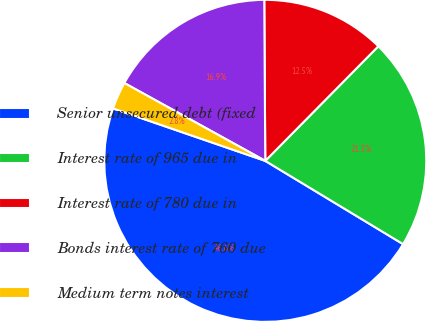Convert chart to OTSL. <chart><loc_0><loc_0><loc_500><loc_500><pie_chart><fcel>Senior unsecured debt (fixed<fcel>Interest rate of 965 due in<fcel>Interest rate of 780 due in<fcel>Bonds interest rate of 760 due<fcel>Medium term notes interest<nl><fcel>46.63%<fcel>21.26%<fcel>12.49%<fcel>16.87%<fcel>2.75%<nl></chart> 